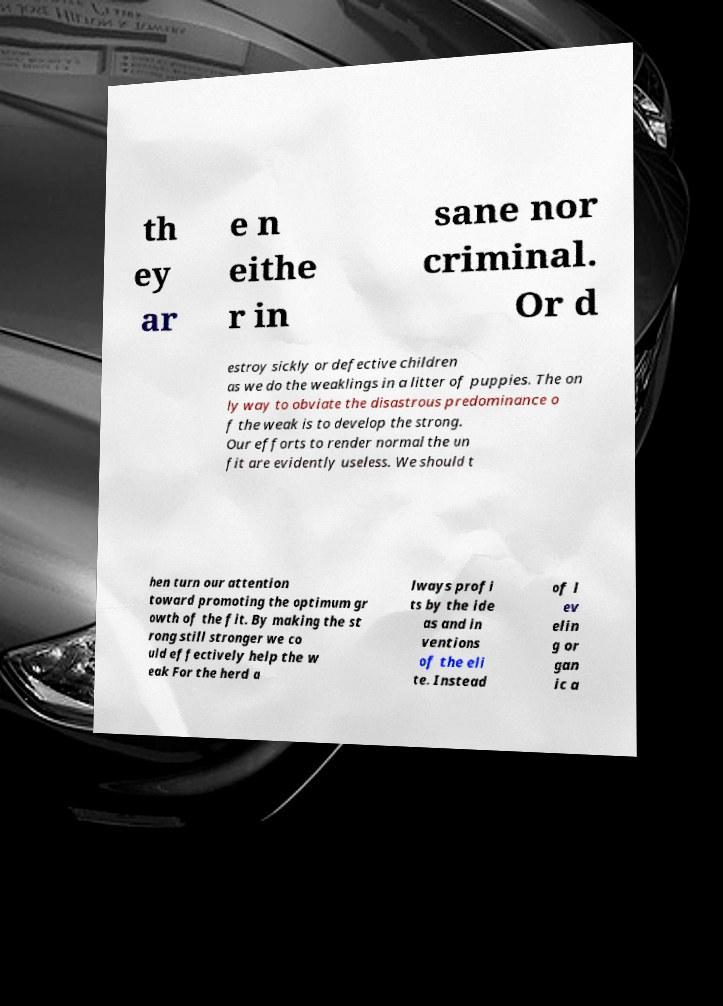Can you accurately transcribe the text from the provided image for me? th ey ar e n eithe r in sane nor criminal. Or d estroy sickly or defective children as we do the weaklings in a litter of puppies. The on ly way to obviate the disastrous predominance o f the weak is to develop the strong. Our efforts to render normal the un fit are evidently useless. We should t hen turn our attention toward promoting the optimum gr owth of the fit. By making the st rong still stronger we co uld effectively help the w eak For the herd a lways profi ts by the ide as and in ventions of the eli te. Instead of l ev elin g or gan ic a 